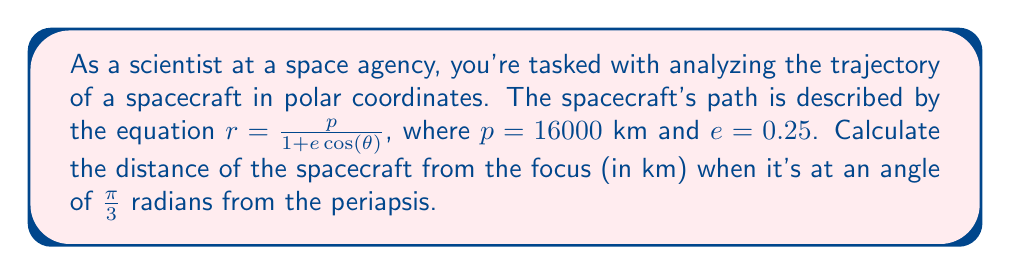Can you solve this math problem? To solve this problem, we'll follow these steps:

1) The equation given is the general form of a conic section in polar coordinates, where:
   $r$ is the distance from the focus
   $p$ is the semi-latus rectum
   $e$ is the eccentricity
   $\theta$ is the angle from the periapsis

2) We're given:
   $p = 16000$ km
   $e = 0.25$
   $\theta = \frac{\pi}{3}$ radians

3) Let's substitute these values into the equation:

   $$r = \frac{16000}{1 + 0.25 \cos(\frac{\pi}{3})}$$

4) Now, we need to calculate $\cos(\frac{\pi}{3})$:
   $\cos(\frac{\pi}{3}) = 0.5$

5) Substituting this value:

   $$r = \frac{16000}{1 + 0.25 (0.5)}$$

6) Simplify:
   $$r = \frac{16000}{1 + 0.125} = \frac{16000}{1.125}$$

7) Calculate the final result:
   $$r = 14222.22 \text{ km}$$

Thus, the spacecraft is approximately 14,222.22 km from the focus when it's at an angle of $\frac{\pi}{3}$ radians from the periapsis.
Answer: $r \approx 14222.22$ km 